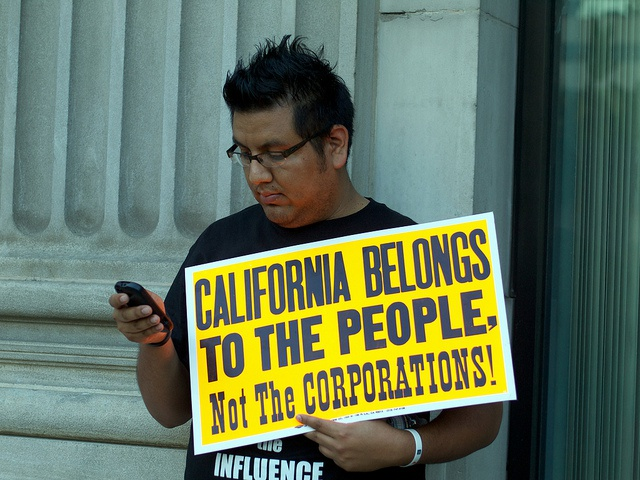Describe the objects in this image and their specific colors. I can see people in gray, black, and maroon tones and cell phone in gray, black, blue, and darkblue tones in this image. 